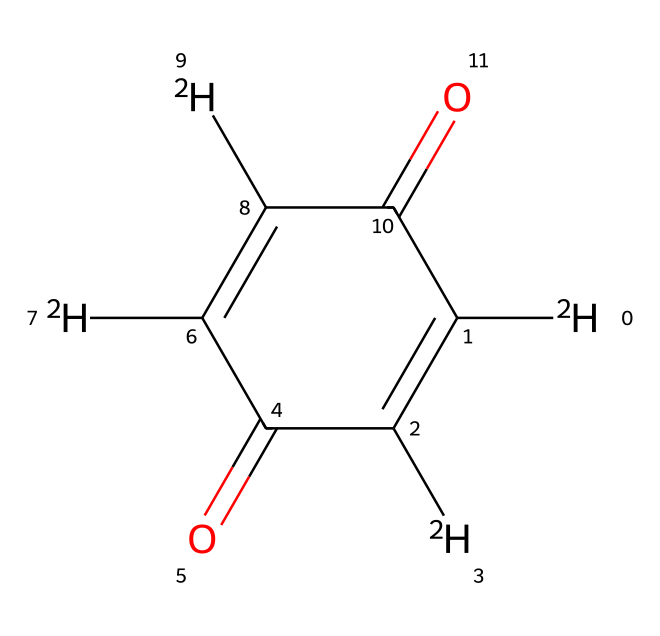What is the molecular formula of this compound? Analyzing the provided SMILES, we can count the different atoms present. The compound includes three distinct types of atoms: carbon (C), oxygen (O), and deuterium (D). For carbon, there are six (C), for oxygen, there are two (O), and for deuterium, there are four ([2H]). Thus, the molecular formula can be represented as C6D4O2.
Answer: C6D4O2 How many carbon atoms are in this compound? By inspecting the SMILES string, we can see the presence of carbon atoms represented by the letter C. There are six instances of C in total, confirming the count of carbon atoms in this chemical structure.
Answer: 6 How many deuterium atoms are present? The SMILES notation includes the deuterium isotopes, represented as [2H]. Counting these occurrences in the structure, we note four instances of [2H], which indicates the total number of deuterium atoms in the compound.
Answer: 4 What type of chemical functional groups are present? To determine the functional groups, we analyze the structure indicated by the SMILES. This compound contains carbonyl groups (C=O), as evidenced by the C=O bonds shown in the structure, and thus can be categorized as featuring two ketone groups, confirming the presence of these specific functionalities.
Answer: ketone Is this compound luminescent? The chemical structure contains deuterium-enriched compounds which often enhance luminescence due to their unique isotopic makeup. While the specific luminescent properties cannot be directly determined from the SMILES alone, the presence of deuterium suggests increased luminescent behaviors are possible in related compounds.
Answer: yes What is the importance of deuterium in this chemical? Deuterium, the heavier isotope of hydrogen, affects the vibrational frequency of bonds involving hydrogen. This altered vibrational state can enhance certain chemical properties, such as luminescence, thereby providing significant advantages in applications like luminescent paints. This shows that deuterium is crucial for modifying the properties of the paint.
Answer: modifies properties 